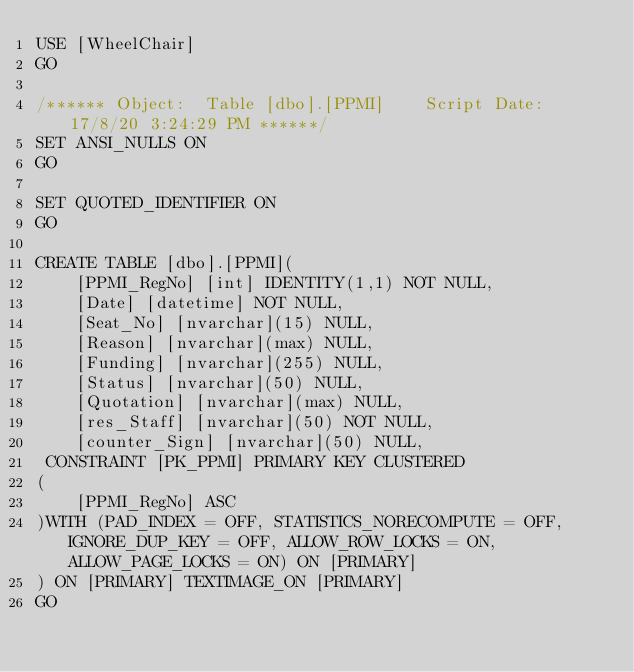Convert code to text. <code><loc_0><loc_0><loc_500><loc_500><_SQL_>USE [WheelChair]
GO

/****** Object:  Table [dbo].[PPMI]    Script Date: 17/8/20 3:24:29 PM ******/
SET ANSI_NULLS ON
GO

SET QUOTED_IDENTIFIER ON
GO

CREATE TABLE [dbo].[PPMI](
	[PPMI_RegNo] [int] IDENTITY(1,1) NOT NULL,
	[Date] [datetime] NOT NULL,
	[Seat_No] [nvarchar](15) NULL,
	[Reason] [nvarchar](max) NULL,
	[Funding] [nvarchar](255) NULL,
	[Status] [nvarchar](50) NULL,
	[Quotation] [nvarchar](max) NULL,
	[res_Staff] [nvarchar](50) NOT NULL,
	[counter_Sign] [nvarchar](50) NULL,
 CONSTRAINT [PK_PPMI] PRIMARY KEY CLUSTERED 
(
	[PPMI_RegNo] ASC
)WITH (PAD_INDEX = OFF, STATISTICS_NORECOMPUTE = OFF, IGNORE_DUP_KEY = OFF, ALLOW_ROW_LOCKS = ON, ALLOW_PAGE_LOCKS = ON) ON [PRIMARY]
) ON [PRIMARY] TEXTIMAGE_ON [PRIMARY]
GO


</code> 